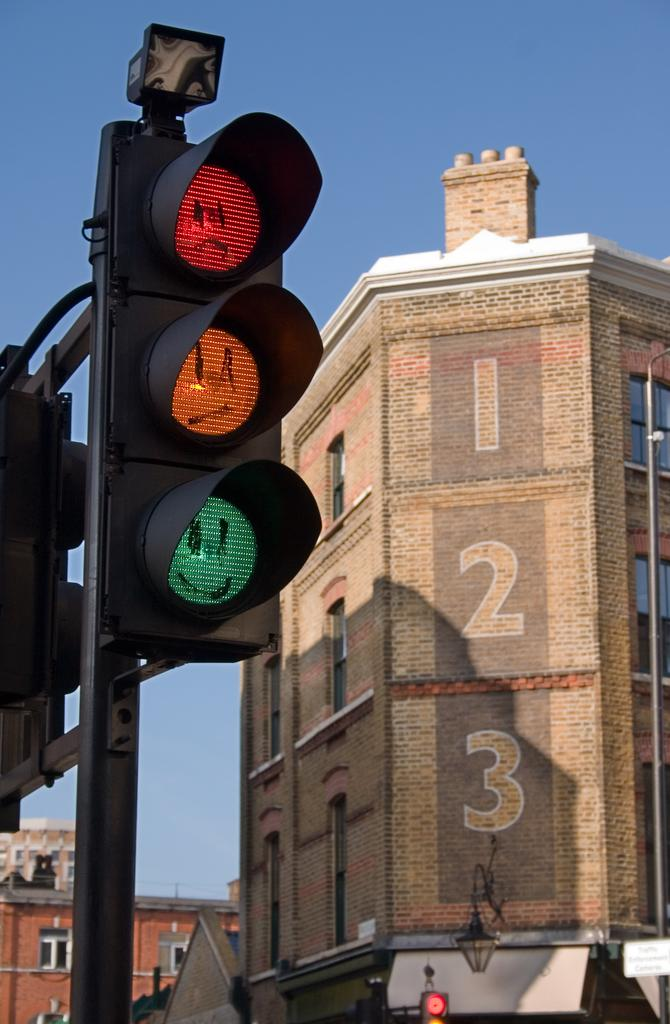<image>
Summarize the visual content of the image. A large brick building that has the numbers 1, 2 and 3 on it. 